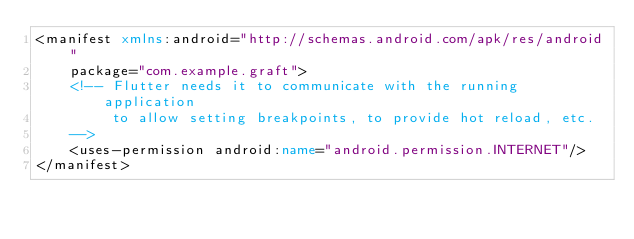<code> <loc_0><loc_0><loc_500><loc_500><_XML_><manifest xmlns:android="http://schemas.android.com/apk/res/android"
    package="com.example.graft">
    <!-- Flutter needs it to communicate with the running application
         to allow setting breakpoints, to provide hot reload, etc.
    -->
    <uses-permission android:name="android.permission.INTERNET"/>
</manifest>
</code> 